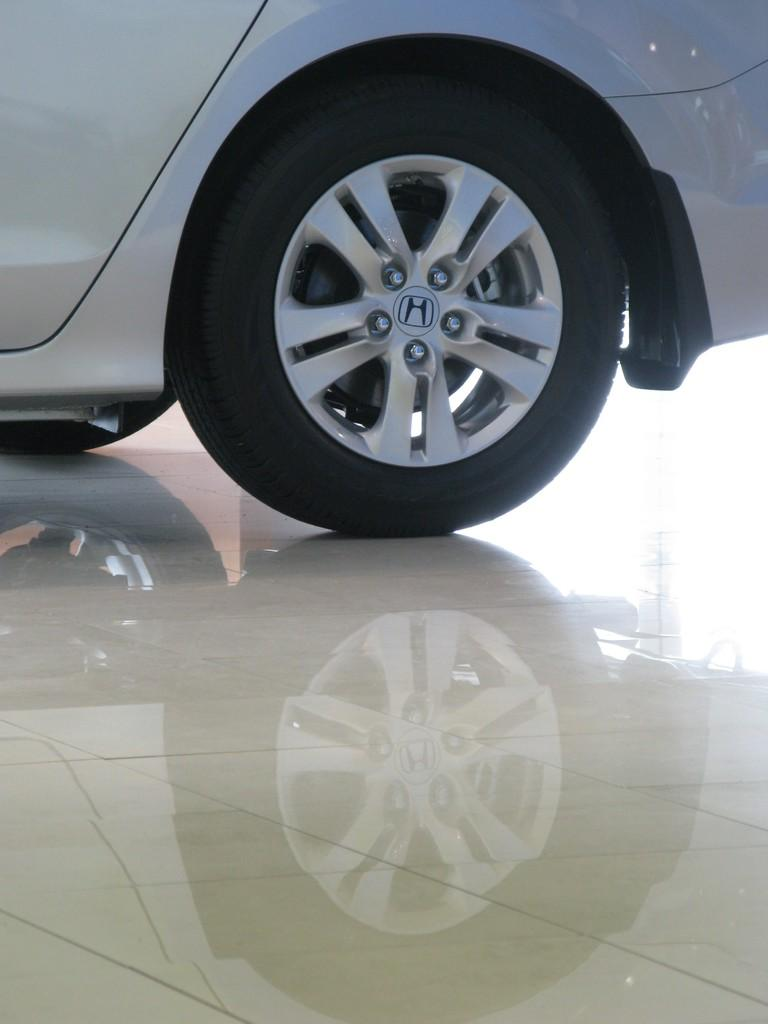What is the main subject of the image? The main subject of the image is a vehicle tire. How many tickets can be seen on the moon in the image? There are no tickets or moons present in the image; it only features a vehicle tire. 